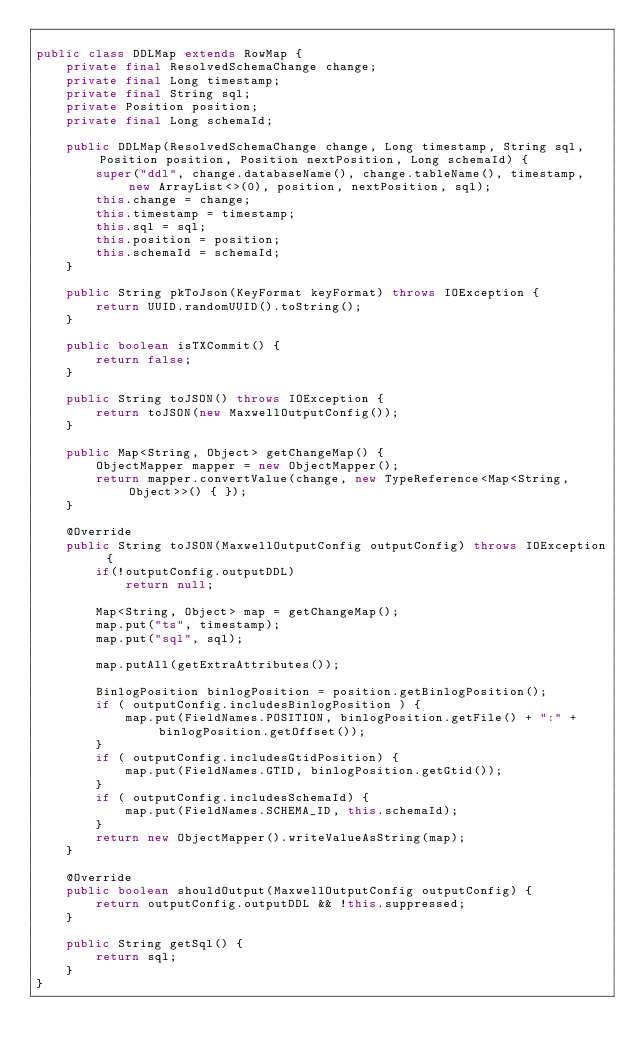Convert code to text. <code><loc_0><loc_0><loc_500><loc_500><_Java_>
public class DDLMap extends RowMap {
	private final ResolvedSchemaChange change;
	private final Long timestamp;
	private final String sql;
	private Position position;
	private final Long schemaId;

	public DDLMap(ResolvedSchemaChange change, Long timestamp, String sql, Position position, Position nextPosition, Long schemaId) {
		super("ddl", change.databaseName(), change.tableName(), timestamp, new ArrayList<>(0), position, nextPosition, sql);
		this.change = change;
		this.timestamp = timestamp;
		this.sql = sql;
		this.position = position;
		this.schemaId = schemaId;
	}

	public String pkToJson(KeyFormat keyFormat) throws IOException {
		return UUID.randomUUID().toString();
	}

	public boolean isTXCommit() {
		return false;
	}

	public String toJSON() throws IOException {
		return toJSON(new MaxwellOutputConfig());
	}

	public Map<String, Object> getChangeMap() {
		ObjectMapper mapper = new ObjectMapper();
		return mapper.convertValue(change, new TypeReference<Map<String, Object>>() { });
	}

	@Override
	public String toJSON(MaxwellOutputConfig outputConfig) throws IOException {
		if(!outputConfig.outputDDL)
			return null;

		Map<String, Object> map = getChangeMap();
		map.put("ts", timestamp);
		map.put("sql", sql);

		map.putAll(getExtraAttributes());

		BinlogPosition binlogPosition = position.getBinlogPosition();
		if ( outputConfig.includesBinlogPosition ) {
			map.put(FieldNames.POSITION, binlogPosition.getFile() + ":" + binlogPosition.getOffset());
		}
		if ( outputConfig.includesGtidPosition) {
			map.put(FieldNames.GTID, binlogPosition.getGtid());
		}
		if ( outputConfig.includesSchemaId) {
			map.put(FieldNames.SCHEMA_ID, this.schemaId);
		}
		return new ObjectMapper().writeValueAsString(map);
	}

	@Override
	public boolean shouldOutput(MaxwellOutputConfig outputConfig) {
		return outputConfig.outputDDL && !this.suppressed;
	}

	public String getSql() {
		return sql;
	}
}
</code> 